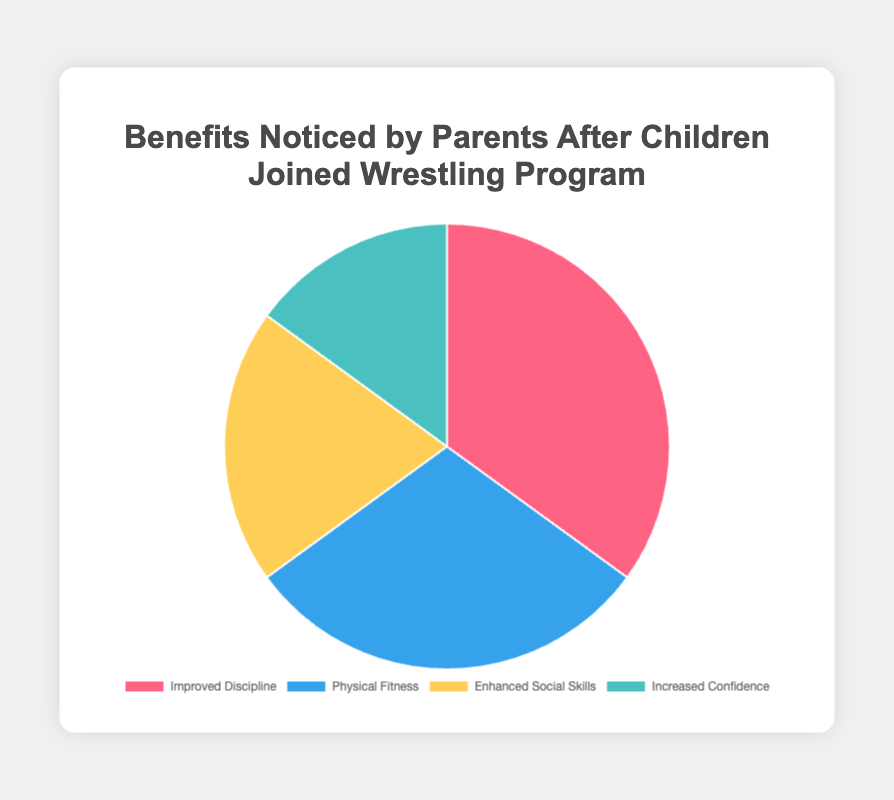What is the most reported benefit noticed by parents after children joined the wrestling program? The figure shows that "Improved Discipline" has the highest percentage at 35%, making it the most reported benefit.
Answer: Improved Discipline Which benefit has the least reported percentage according to the parents? By reviewing the figure, it is clear that "Increased Confidence" has the lowest percentage at 15%, making it the least reported benefit.
Answer: Increased Confidence What is the percentage difference between the most reported benefit and the least reported benefit? The most reported benefit is "Improved Discipline" at 35% and the least is "Increased Confidence" at 15%. The difference is calculated as 35% - 15% = 20%.
Answer: 20% What is the total percentage of benefits related to social and physical improvements? Adding the percentages of "Physical Fitness" (30%) and "Enhanced Social Skills" (20%) gives a total of 30% + 20% = 50%.
Answer: 50% Are there more reported benefits related to physical aspects or social aspects? "Physical Fitness" accounts for 30%, while "Enhanced Social Skills" accounts for 20%. Since 30% is greater than 20%, there are more reported benefits related to physical aspects.
Answer: Physical Aspects Which benefits have more than 20% of parents reporting them? "Improved Discipline" has 35% and "Physical Fitness" has 30%, both of which are greater than 20%. "Enhanced Social Skills" and "Increased Confidence" are below 20%.
Answer: Improved Discipline and Physical Fitness What is the combined percentage of the two least reported benefits? The two least reported benefits are "Enhanced Social Skills" (20%) and "Increased Confidence" (15%). Summing these gives 20% + 15% = 35%.
Answer: 35% Which color represents the benefit with the lowest percentage, and what is that percentage? The legend of the pie chart shows "Increased Confidence" is represented by a light blue color, which has a reported percentage of 15%.
Answer: Light Blue, 15% Is the percentage of "Improved Discipline" greater than the combined percentage of "Enhanced Social Skills" and "Increased Confidence"? "Improved Discipline" has a percentage of 35%. The combined percentage of "Enhanced Social Skills" (20%) and "Increased Confidence" (15%) is 20% + 15% = 35%, which equals the percentage of "Improved Discipline".
Answer: No, they are equal How many benefits have a reported percentage less than 25%? "Enhanced Social Skills" (20%) and "Increased Confidence" (15%) are both below 25%, making the total number of benefits with less than 25% two.
Answer: 2 